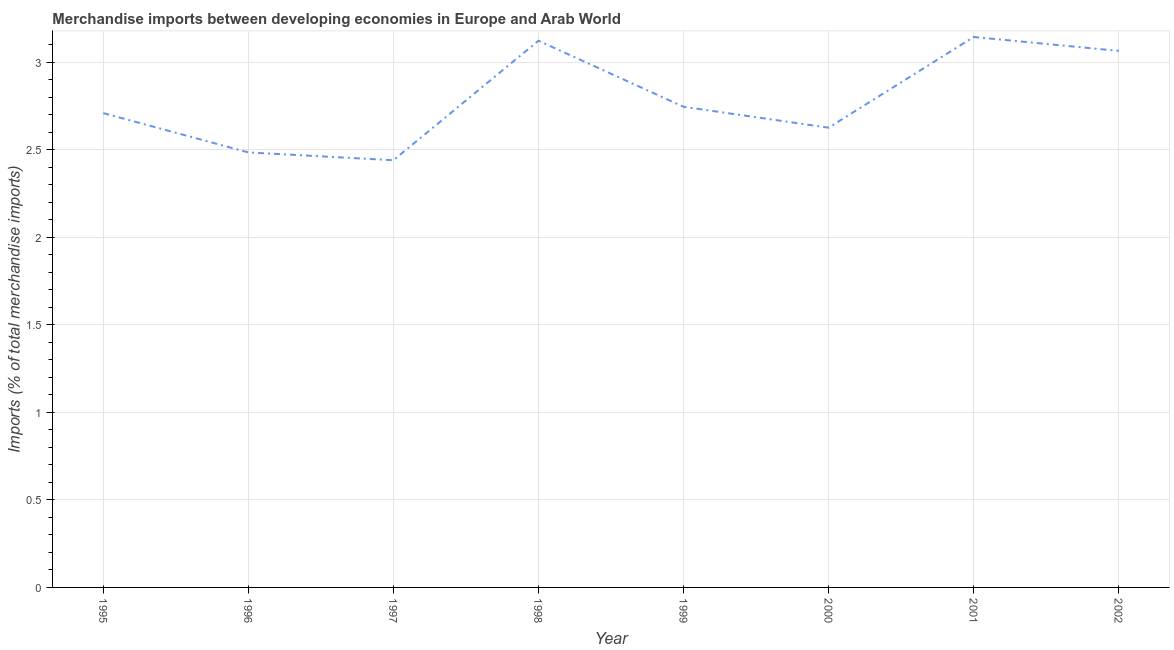What is the merchandise imports in 2001?
Offer a very short reply. 3.14. Across all years, what is the maximum merchandise imports?
Your answer should be compact. 3.14. Across all years, what is the minimum merchandise imports?
Keep it short and to the point. 2.44. In which year was the merchandise imports maximum?
Offer a very short reply. 2001. In which year was the merchandise imports minimum?
Keep it short and to the point. 1997. What is the sum of the merchandise imports?
Your answer should be compact. 22.33. What is the difference between the merchandise imports in 1995 and 2001?
Your response must be concise. -0.43. What is the average merchandise imports per year?
Keep it short and to the point. 2.79. What is the median merchandise imports?
Provide a short and direct response. 2.73. What is the ratio of the merchandise imports in 1999 to that in 2002?
Your response must be concise. 0.9. What is the difference between the highest and the second highest merchandise imports?
Your response must be concise. 0.02. What is the difference between the highest and the lowest merchandise imports?
Your answer should be very brief. 0.7. Does the merchandise imports monotonically increase over the years?
Your response must be concise. No. How many lines are there?
Provide a succinct answer. 1. How many years are there in the graph?
Keep it short and to the point. 8. What is the title of the graph?
Your answer should be compact. Merchandise imports between developing economies in Europe and Arab World. What is the label or title of the X-axis?
Offer a very short reply. Year. What is the label or title of the Y-axis?
Give a very brief answer. Imports (% of total merchandise imports). What is the Imports (% of total merchandise imports) of 1995?
Offer a very short reply. 2.71. What is the Imports (% of total merchandise imports) of 1996?
Ensure brevity in your answer.  2.48. What is the Imports (% of total merchandise imports) in 1997?
Provide a short and direct response. 2.44. What is the Imports (% of total merchandise imports) of 1998?
Offer a very short reply. 3.12. What is the Imports (% of total merchandise imports) of 1999?
Provide a short and direct response. 2.74. What is the Imports (% of total merchandise imports) of 2000?
Keep it short and to the point. 2.63. What is the Imports (% of total merchandise imports) in 2001?
Make the answer very short. 3.14. What is the Imports (% of total merchandise imports) in 2002?
Your answer should be very brief. 3.06. What is the difference between the Imports (% of total merchandise imports) in 1995 and 1996?
Your answer should be compact. 0.22. What is the difference between the Imports (% of total merchandise imports) in 1995 and 1997?
Your answer should be very brief. 0.27. What is the difference between the Imports (% of total merchandise imports) in 1995 and 1998?
Give a very brief answer. -0.41. What is the difference between the Imports (% of total merchandise imports) in 1995 and 1999?
Offer a terse response. -0.04. What is the difference between the Imports (% of total merchandise imports) in 1995 and 2000?
Keep it short and to the point. 0.08. What is the difference between the Imports (% of total merchandise imports) in 1995 and 2001?
Keep it short and to the point. -0.43. What is the difference between the Imports (% of total merchandise imports) in 1995 and 2002?
Provide a succinct answer. -0.36. What is the difference between the Imports (% of total merchandise imports) in 1996 and 1997?
Give a very brief answer. 0.04. What is the difference between the Imports (% of total merchandise imports) in 1996 and 1998?
Your answer should be compact. -0.64. What is the difference between the Imports (% of total merchandise imports) in 1996 and 1999?
Your response must be concise. -0.26. What is the difference between the Imports (% of total merchandise imports) in 1996 and 2000?
Give a very brief answer. -0.14. What is the difference between the Imports (% of total merchandise imports) in 1996 and 2001?
Your response must be concise. -0.66. What is the difference between the Imports (% of total merchandise imports) in 1996 and 2002?
Offer a terse response. -0.58. What is the difference between the Imports (% of total merchandise imports) in 1997 and 1998?
Provide a short and direct response. -0.68. What is the difference between the Imports (% of total merchandise imports) in 1997 and 1999?
Provide a succinct answer. -0.31. What is the difference between the Imports (% of total merchandise imports) in 1997 and 2000?
Make the answer very short. -0.19. What is the difference between the Imports (% of total merchandise imports) in 1997 and 2001?
Your answer should be very brief. -0.7. What is the difference between the Imports (% of total merchandise imports) in 1997 and 2002?
Ensure brevity in your answer.  -0.62. What is the difference between the Imports (% of total merchandise imports) in 1998 and 1999?
Offer a very short reply. 0.38. What is the difference between the Imports (% of total merchandise imports) in 1998 and 2000?
Your answer should be compact. 0.5. What is the difference between the Imports (% of total merchandise imports) in 1998 and 2001?
Offer a terse response. -0.02. What is the difference between the Imports (% of total merchandise imports) in 1998 and 2002?
Keep it short and to the point. 0.06. What is the difference between the Imports (% of total merchandise imports) in 1999 and 2000?
Keep it short and to the point. 0.12. What is the difference between the Imports (% of total merchandise imports) in 1999 and 2001?
Make the answer very short. -0.4. What is the difference between the Imports (% of total merchandise imports) in 1999 and 2002?
Keep it short and to the point. -0.32. What is the difference between the Imports (% of total merchandise imports) in 2000 and 2001?
Provide a short and direct response. -0.52. What is the difference between the Imports (% of total merchandise imports) in 2000 and 2002?
Provide a short and direct response. -0.44. What is the difference between the Imports (% of total merchandise imports) in 2001 and 2002?
Provide a short and direct response. 0.08. What is the ratio of the Imports (% of total merchandise imports) in 1995 to that in 1996?
Offer a terse response. 1.09. What is the ratio of the Imports (% of total merchandise imports) in 1995 to that in 1997?
Provide a succinct answer. 1.11. What is the ratio of the Imports (% of total merchandise imports) in 1995 to that in 1998?
Your response must be concise. 0.87. What is the ratio of the Imports (% of total merchandise imports) in 1995 to that in 1999?
Your answer should be compact. 0.99. What is the ratio of the Imports (% of total merchandise imports) in 1995 to that in 2000?
Provide a short and direct response. 1.03. What is the ratio of the Imports (% of total merchandise imports) in 1995 to that in 2001?
Offer a terse response. 0.86. What is the ratio of the Imports (% of total merchandise imports) in 1995 to that in 2002?
Your answer should be very brief. 0.88. What is the ratio of the Imports (% of total merchandise imports) in 1996 to that in 1997?
Offer a very short reply. 1.02. What is the ratio of the Imports (% of total merchandise imports) in 1996 to that in 1998?
Give a very brief answer. 0.8. What is the ratio of the Imports (% of total merchandise imports) in 1996 to that in 1999?
Offer a very short reply. 0.91. What is the ratio of the Imports (% of total merchandise imports) in 1996 to that in 2000?
Make the answer very short. 0.95. What is the ratio of the Imports (% of total merchandise imports) in 1996 to that in 2001?
Keep it short and to the point. 0.79. What is the ratio of the Imports (% of total merchandise imports) in 1996 to that in 2002?
Offer a terse response. 0.81. What is the ratio of the Imports (% of total merchandise imports) in 1997 to that in 1998?
Your answer should be compact. 0.78. What is the ratio of the Imports (% of total merchandise imports) in 1997 to that in 1999?
Provide a short and direct response. 0.89. What is the ratio of the Imports (% of total merchandise imports) in 1997 to that in 2000?
Your response must be concise. 0.93. What is the ratio of the Imports (% of total merchandise imports) in 1997 to that in 2001?
Your answer should be very brief. 0.78. What is the ratio of the Imports (% of total merchandise imports) in 1997 to that in 2002?
Your response must be concise. 0.8. What is the ratio of the Imports (% of total merchandise imports) in 1998 to that in 1999?
Provide a succinct answer. 1.14. What is the ratio of the Imports (% of total merchandise imports) in 1998 to that in 2000?
Provide a short and direct response. 1.19. What is the ratio of the Imports (% of total merchandise imports) in 1998 to that in 2002?
Offer a very short reply. 1.02. What is the ratio of the Imports (% of total merchandise imports) in 1999 to that in 2000?
Make the answer very short. 1.04. What is the ratio of the Imports (% of total merchandise imports) in 1999 to that in 2001?
Your answer should be compact. 0.87. What is the ratio of the Imports (% of total merchandise imports) in 1999 to that in 2002?
Give a very brief answer. 0.9. What is the ratio of the Imports (% of total merchandise imports) in 2000 to that in 2001?
Make the answer very short. 0.83. What is the ratio of the Imports (% of total merchandise imports) in 2000 to that in 2002?
Your answer should be compact. 0.86. What is the ratio of the Imports (% of total merchandise imports) in 2001 to that in 2002?
Make the answer very short. 1.03. 